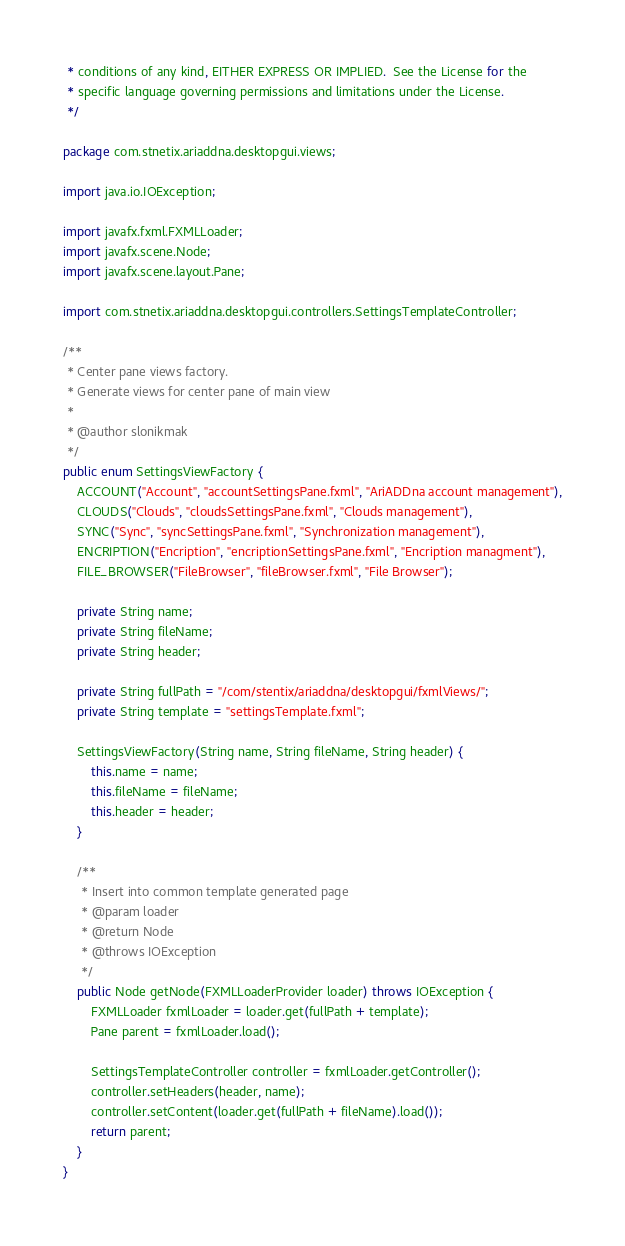<code> <loc_0><loc_0><loc_500><loc_500><_Java_> * conditions of any kind, EITHER EXPRESS OR IMPLIED.  See the License for the
 * specific language governing permissions and limitations under the License.
 */

package com.stnetix.ariaddna.desktopgui.views;

import java.io.IOException;

import javafx.fxml.FXMLLoader;
import javafx.scene.Node;
import javafx.scene.layout.Pane;

import com.stnetix.ariaddna.desktopgui.controllers.SettingsTemplateController;

/**
 * Center pane views factory.
 * Generate views for center pane of main view
 *
 * @author slonikmak
 */
public enum SettingsViewFactory {
    ACCOUNT("Account", "accountSettingsPane.fxml", "AriADDna account management"),
    CLOUDS("Clouds", "cloudsSettingsPane.fxml", "Clouds management"),
    SYNC("Sync", "syncSettingsPane.fxml", "Synchronization management"),
    ENCRIPTION("Encription", "encriptionSettingsPane.fxml", "Encription managment"),
    FILE_BROWSER("FileBrowser", "fileBrowser.fxml", "File Browser");

    private String name;
    private String fileName;
    private String header;

    private String fullPath = "/com/stentix/ariaddna/desktopgui/fxmlViews/";
    private String template = "settingsTemplate.fxml";

    SettingsViewFactory(String name, String fileName, String header) {
        this.name = name;
        this.fileName = fileName;
        this.header = header;
    }

    /**
     * Insert into common template generated page
     * @param loader
     * @return Node
     * @throws IOException
     */
    public Node getNode(FXMLLoaderProvider loader) throws IOException {
        FXMLLoader fxmlLoader = loader.get(fullPath + template);
        Pane parent = fxmlLoader.load();

        SettingsTemplateController controller = fxmlLoader.getController();
        controller.setHeaders(header, name);
        controller.setContent(loader.get(fullPath + fileName).load());
        return parent;
    }
}
</code> 